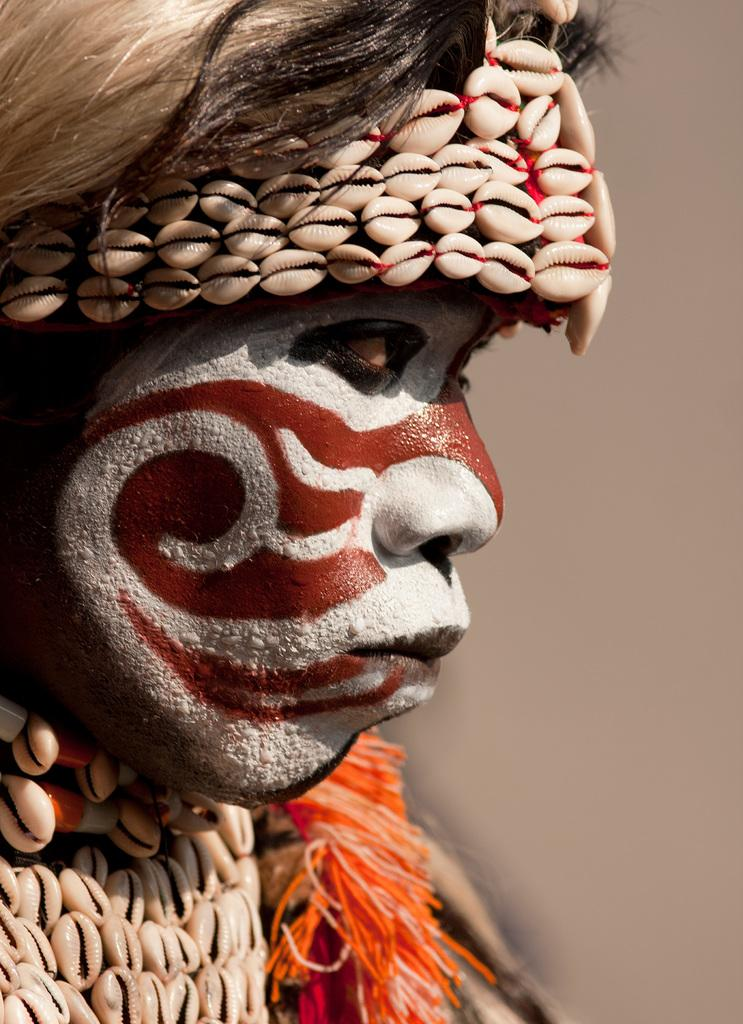What is the main subject of the image? There is a face of a person in the image. How many flowers are present in the image? There is no flower present in the image; it features the face of a person. What type of yak can be seen in the image? There is no yak present in the image; it features the face of a person. 